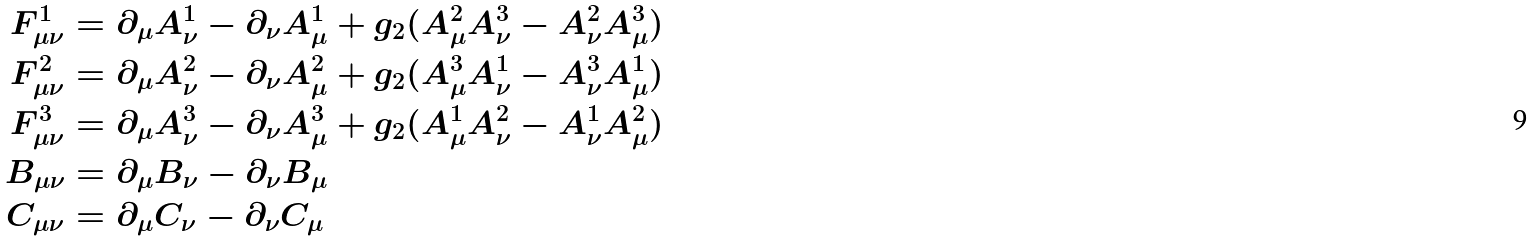Convert formula to latex. <formula><loc_0><loc_0><loc_500><loc_500>F ^ { 1 } _ { \mu \nu } & = \partial _ { \mu } A ^ { 1 } _ { \nu } - \partial _ { \nu } A ^ { 1 } _ { \mu } + g _ { 2 } ( A ^ { 2 } _ { \mu } A ^ { 3 } _ { \nu } - A ^ { 2 } _ { \nu } A ^ { 3 } _ { \mu } ) \\ F ^ { 2 } _ { \mu \nu } & = \partial _ { \mu } A ^ { 2 } _ { \nu } - \partial _ { \nu } A ^ { 2 } _ { \mu } + g _ { 2 } ( A ^ { 3 } _ { \mu } A ^ { 1 } _ { \nu } - A ^ { 3 } _ { \nu } A ^ { 1 } _ { \mu } ) \\ F ^ { 3 } _ { \mu \nu } & = \partial _ { \mu } A ^ { 3 } _ { \nu } - \partial _ { \nu } A ^ { 3 } _ { \mu } + g _ { 2 } ( A ^ { 1 } _ { \mu } A ^ { 2 } _ { \nu } - A ^ { 1 } _ { \nu } A ^ { 2 } _ { \mu } ) \\ B _ { \mu \nu } & = \partial _ { \mu } B _ { \nu } - \partial _ { \nu } B _ { \mu } \\ C _ { \mu \nu } & = \partial _ { \mu } C _ { \nu } - \partial _ { \nu } C _ { \mu }</formula> 